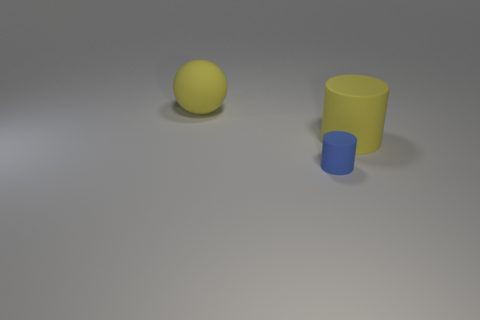Can you describe the lighting and shadows in the picture? The lighting in the image appears to be coming from the upper left side, judging by the shadows cast to the lower right of the two objects. This creates a calm and soft ambiance within the scene. 